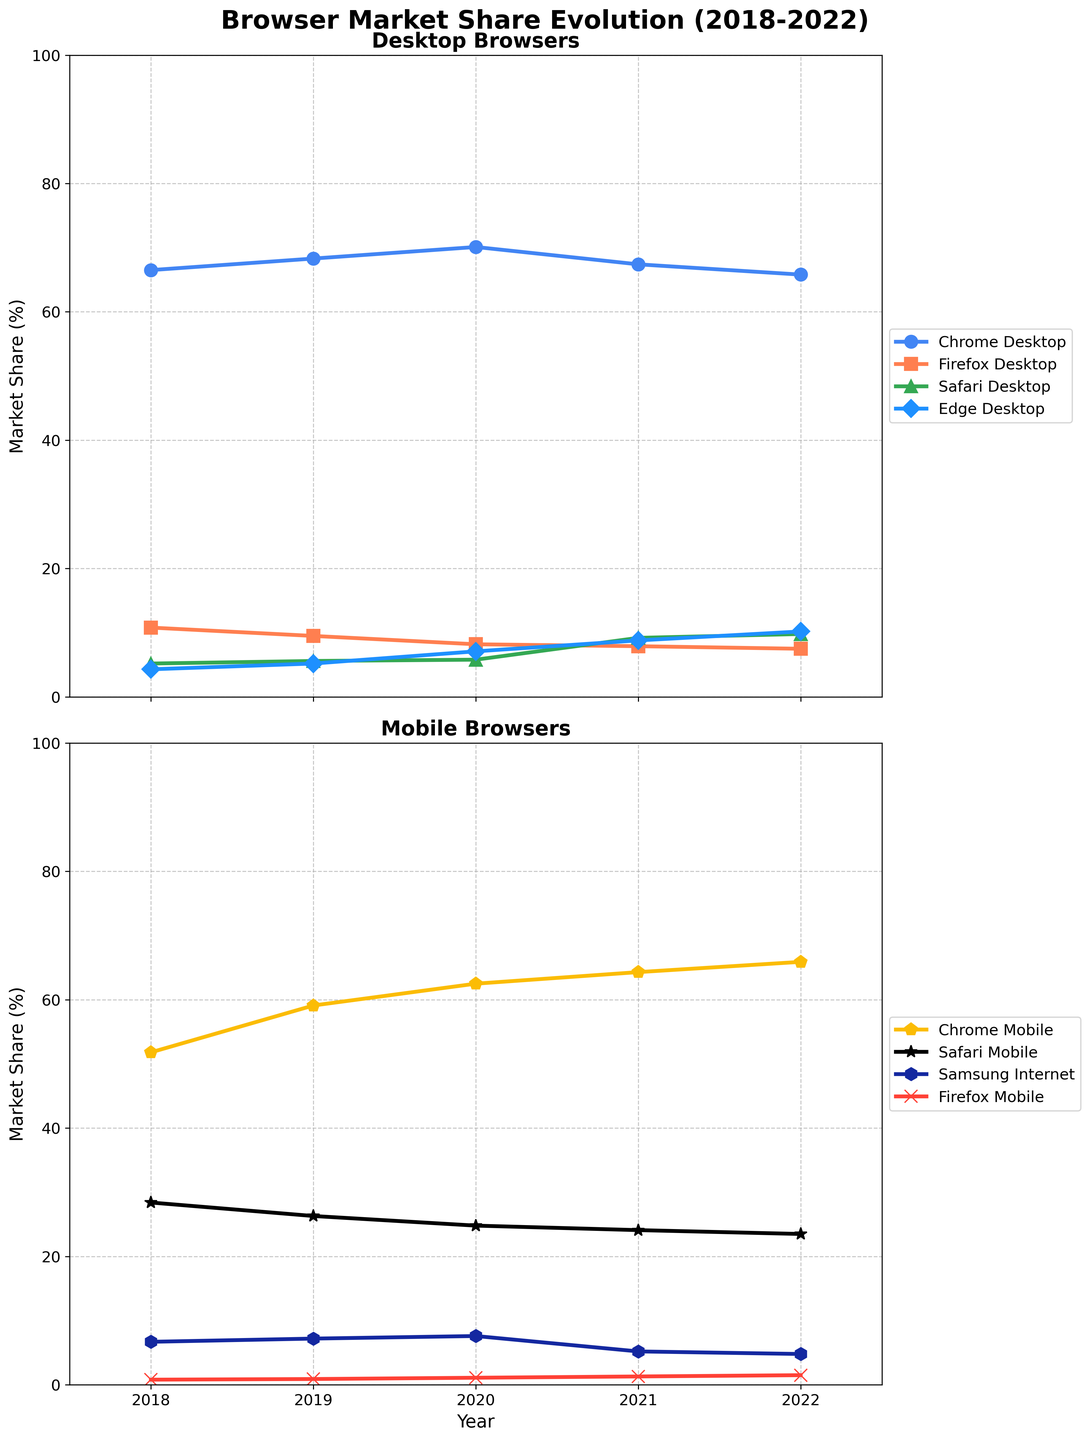What was the market share of Chrome Desktop in 2019? To determine this, locate the line representing Chrome Desktop in the upper chart and find its value for the year 2019.
Answer: 68.3 Which browser had the highest market share on mobile platforms in 2020? Check the lower chart for the year 2020 and identify which browser line is the highest.
Answer: Chrome Mobile By how much did Safari Desktop's market share change from 2018 to 2022? Subtract Safari Desktop's market share in 2018 from its share in 2022. 9.8 - 5.2 = 4.6
Answer: 4.6 Compare Chrome Desktop and Edge Desktop in 2021. Which had a higher market share, and by how much? Locate both lines in the upper chart for the year 2021, find their market values, and calculate the difference (Chrome Desktop - Edge Desktop). 67.4 - 8.8 = 58.6
Answer: Chrome Desktop by 58.6 What's the average market share of Firefox Desktop over the five years? Sum the market shares for Firefox Desktop for each year and divide by the number of years (5). (10.8 + 9.5 + 8.2 + 7.9 + 7.5) / 5 = 8.78
Answer: 8.78 Did Samsung Internet's market share increase or decrease from 2021 to 2022? Compare the values for Samsung Internet in 2021 and 2022.
Answer: Decrease Which browser showed the largest increase in market share on mobile platforms from 2018 to 2022? Calculate the change in market share for each mobile browser from 2018 to 2022 and identify the largest increase. (Chrome Mobile: 65.9 - 51.8 = 14.1).
Answer: Chrome Mobile How does the market share of Safari Mobile in 2022 compare to Safari Desktop in the same year? Locate both values for Safari Mobile and Safari Desktop in 2022 and compare them.
Answer: Safari Mobile is higher Between Firefox Mobile and Firefox Desktop, which had a higher market share in 2020? Compare the two values on their respective lines for the year 2020.
Answer: Firefox Desktop Which year did Edge Desktop see the most significant gain in market share? Identify the year-to-year differences for Edge Desktop and find the year with the largest gain. Difference: 2020-2019 = 7.1 - 5.2 = 1.9
Answer: 2021 